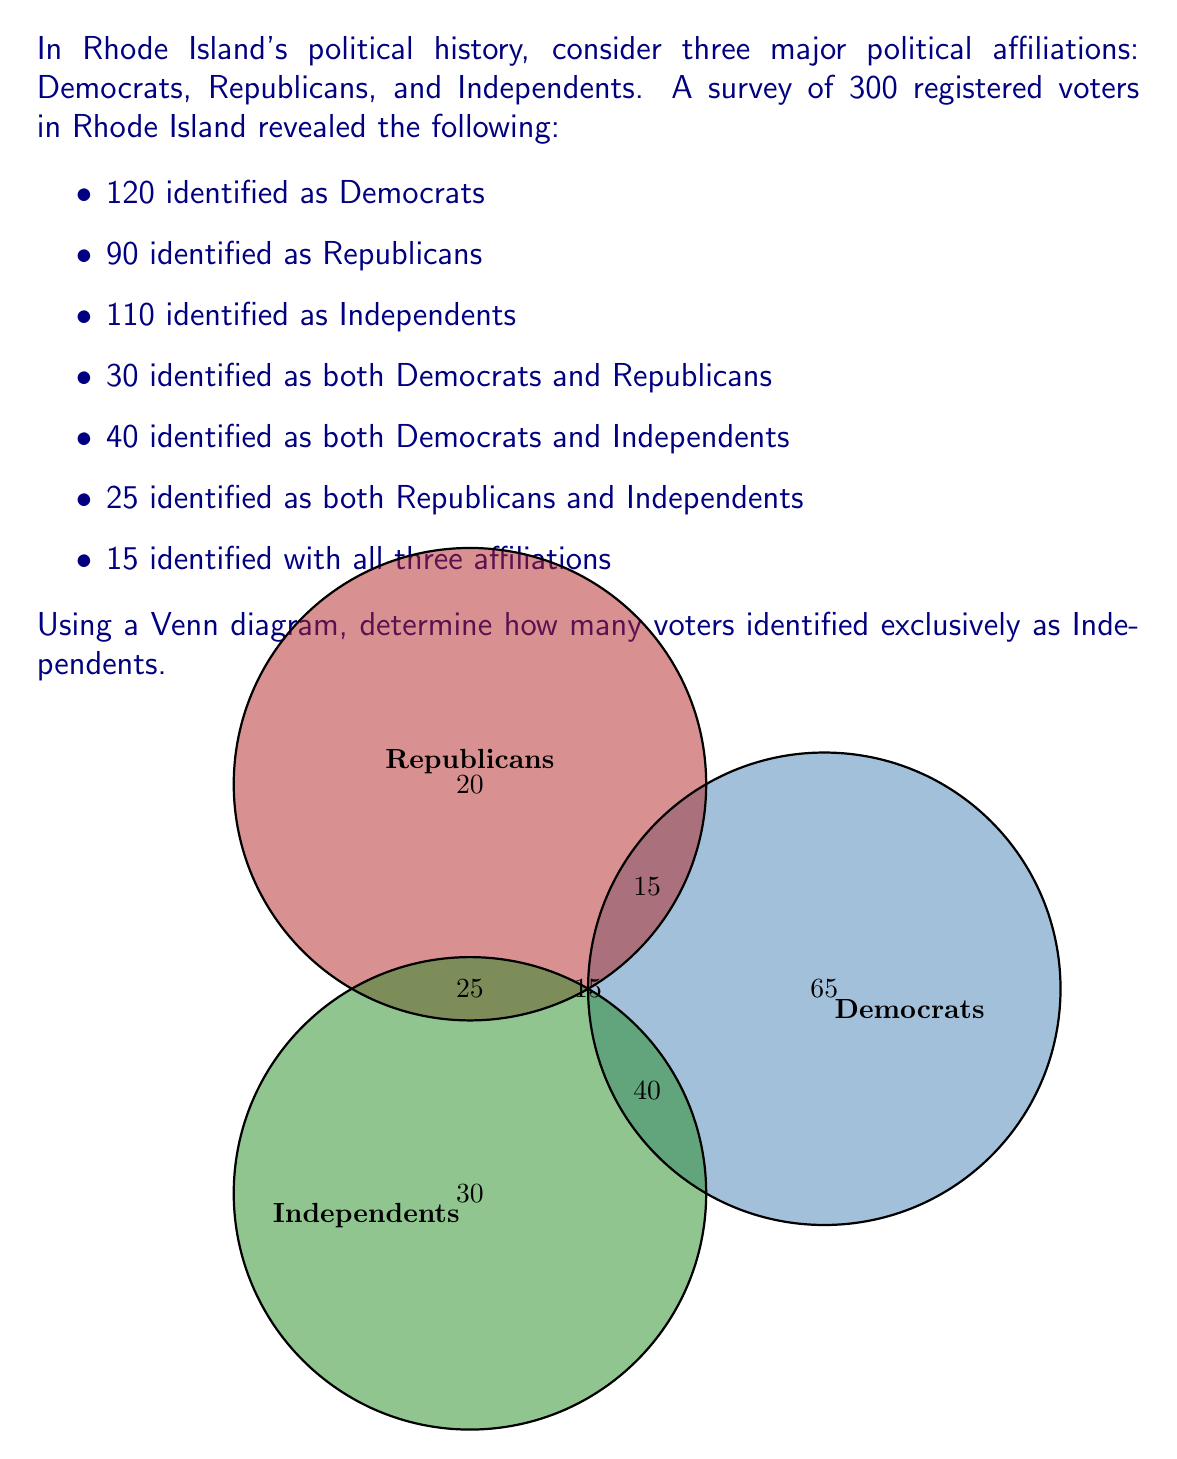Give your solution to this math problem. Let's approach this step-by-step using the given information and the properties of Venn diagrams:

1) First, let's identify the number in the center of the Venn diagram (those who identify with all three affiliations):
   $15$

2) Now, let's calculate the numbers for the overlapping regions between two affiliations:
   - Democrats and Republicans: $30 - 15 = 15$
   - Democrats and Independents: $40 - 15 = 25$
   - Republicans and Independents: $25 - 15 = 10$

3) Next, we can calculate the numbers for each affiliation exclusively:
   - Democrats only: $120 - (15 + 15 + 25) = 65$
   - Republicans only: $90 - (15 + 15 + 10) = 50$
   - Independents only: Let this be $x$

4) We can now set up an equation based on the total number of Independents:
   $$x + 25 + 10 + 15 = 110$$

5) Solve for $x$:
   $$x = 110 - (25 + 10 + 15) = 110 - 50 = 60$$

Therefore, 60 voters identified exclusively as Independents.

6) As a final check, we can verify that the sum of all regions equals the total number of surveyed voters:
   $65 + 50 + 60 + 15 + 25 + 10 + 15 = 240$
   This matches the given total of 300 voters.
Answer: 60 voters 